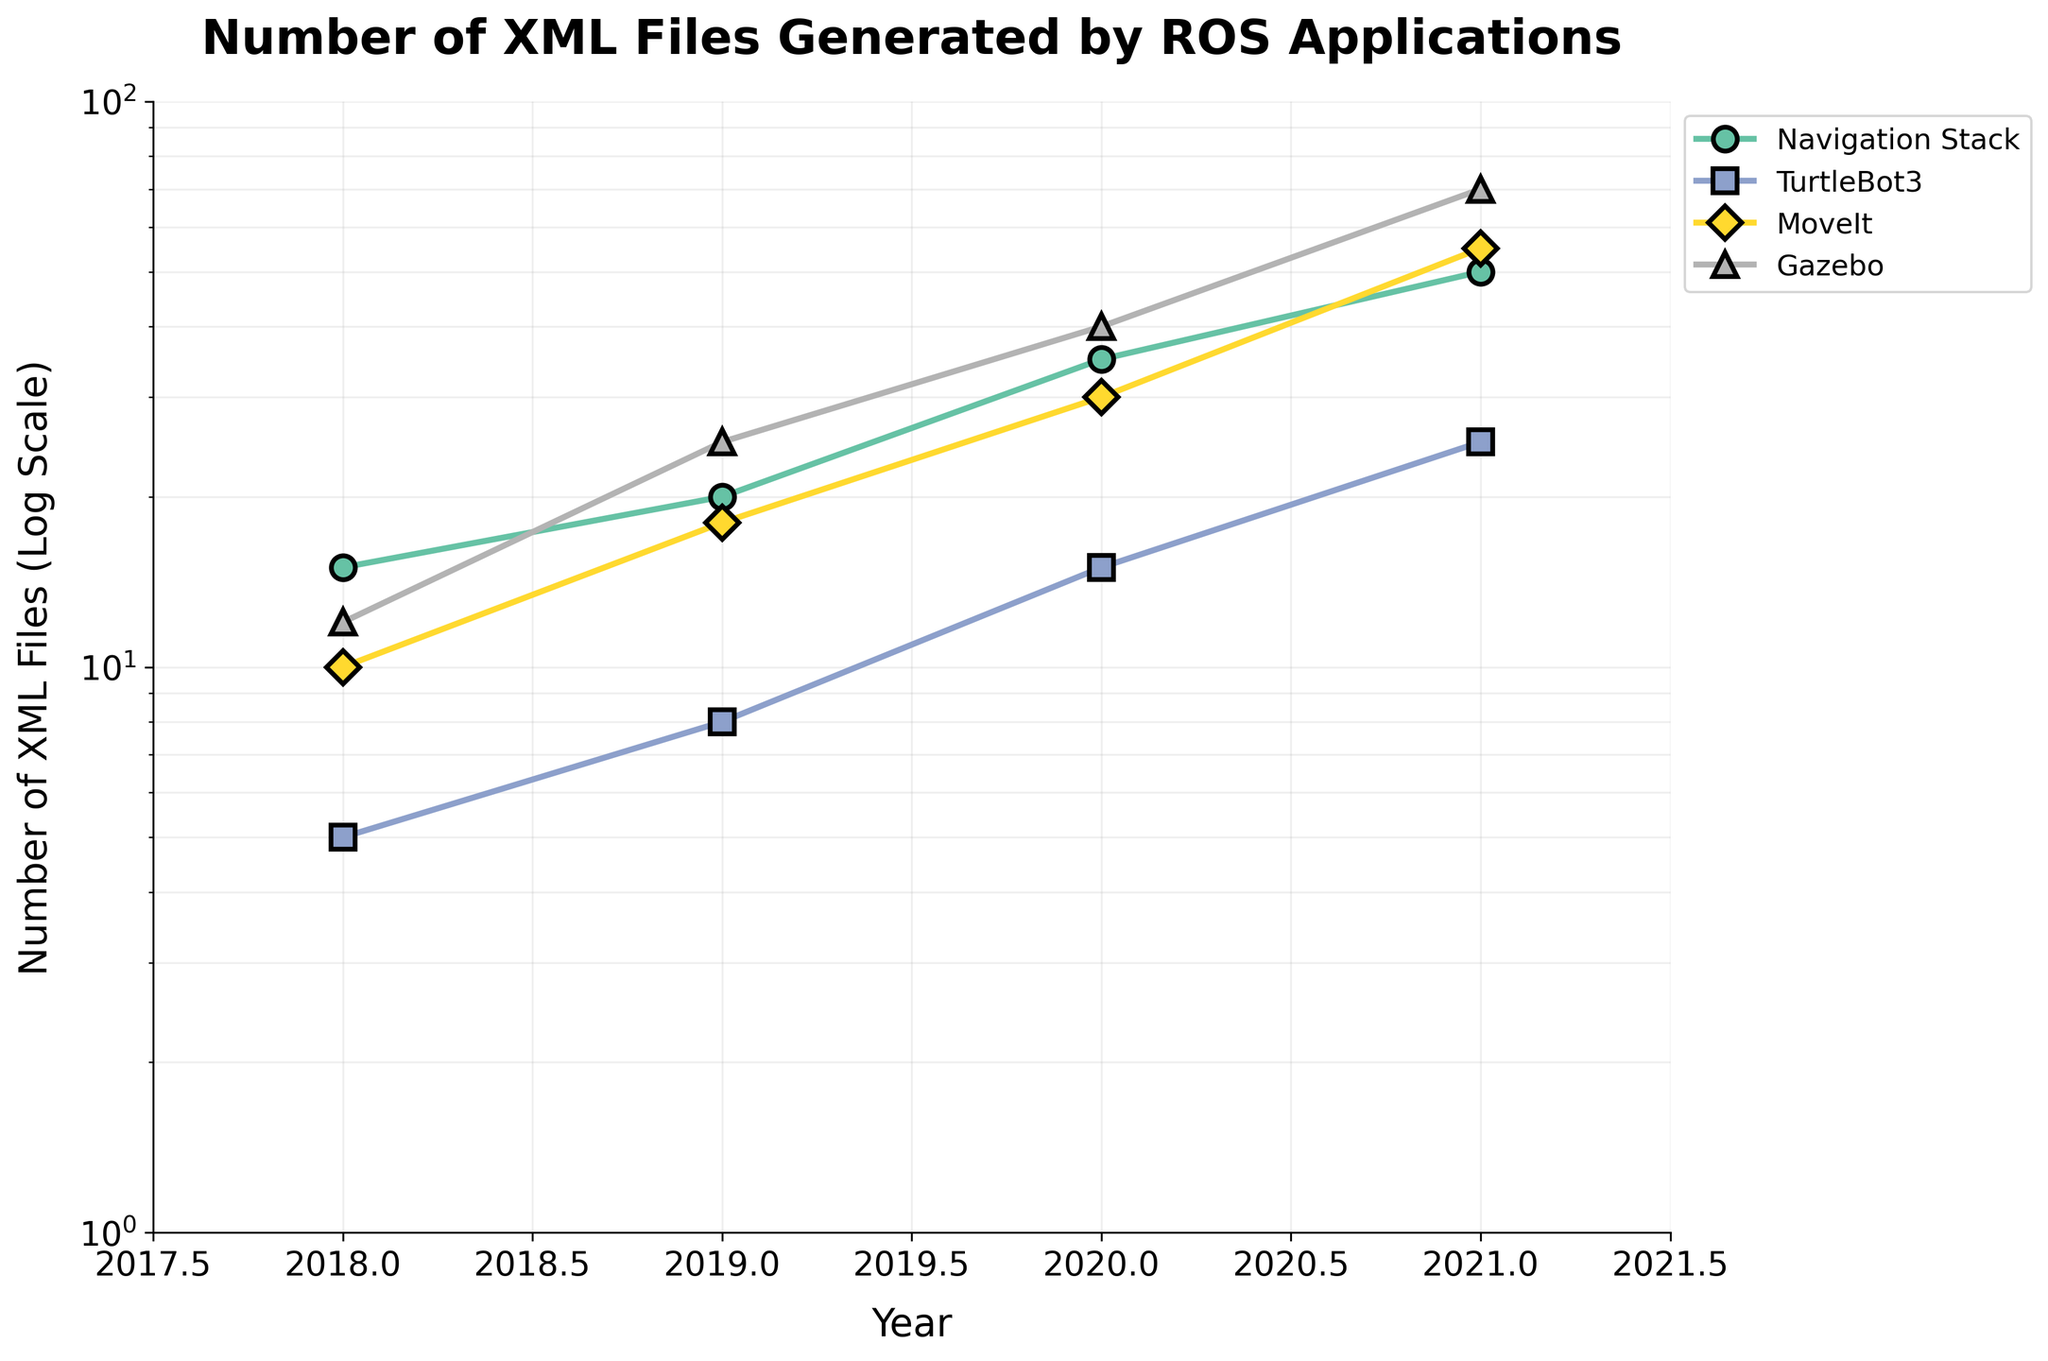What is the title of the figure? The title is displayed at the top of the figure, providing a summary of what the plot represents. In this case, it tells us that the figure shows the number of XML files generated by ROS applications.
Answer: Number of XML Files Generated by ROS Applications Which application generated the highest number of XML files in 2021? By examining the y-axis value for the year 2021, we can see which application has the highest point. Gazebo reaches up to 70 XML files, which is higher than all other applications in the same year.
Answer: Gazebo What is the range of the y-axis in the figure? The y-axis values are shown from the bottom to the top of the plot. In this figure, the y-axis starts at 1 and goes up to 100.
Answer: 1 to 100 Which application showed the smallest increase in the number of XML files from 2018 to 2019? By comparing the vertical difference between data points of each application from 2018 to 2019, we can determine the smallest increase. TurtleBot3 increased from 5 to 8, which is the smallest increase compared to other applications.
Answer: TurtleBot3 What data is represented on the x and y axes? The x-axis of the plot represents the years from 2018 to 2021, and the y-axis represents the number of XML files (on a logarithmic scale). This information is essential to understanding what the data points represent.
Answer: x-axis: Years, y-axis: Number of XML Files How many XML files were generated by the Navigation Stack in 2020? Locate the year 2020 on the x-axis and then check the corresponding y-axis value for the Navigation Stack's data point. It reaches up to 35 XML files.
Answer: 35 Which year showed the greatest overall increase in the number of XML files across all applications? By examining the trend lines for each application, we can see which year had the steepest slopes. From 2020 to 2021, all applications show significant increases, indicating this year had the greatest overall increase.
Answer: From 2020 to 2021 Which application had the steepest increase in the number of XML files between any two consecutive years, and what was the value of the increase? By observing the slopes of the lines, we see that Gazebo had the steepest increase from 2019 to 2020, where it went from 25 to 40 XML files. The increase in value is 15.
Answer: Gazebo, 15 For the year 2018, rank the applications based on the number of XML files generated in descending order. Check the y-axis values for 2018 and then list the applications from the highest to the lowest value. MoveIt generated 10, Gazebo 12, Navigation Stack 15, and TurtleBot3 5 XML files. The descending order is Navigation Stack, Gazebo, MoveIt, and TurtleBot3.
Answer: Navigation Stack > Gazebo > MoveIt > TurtleBot3 